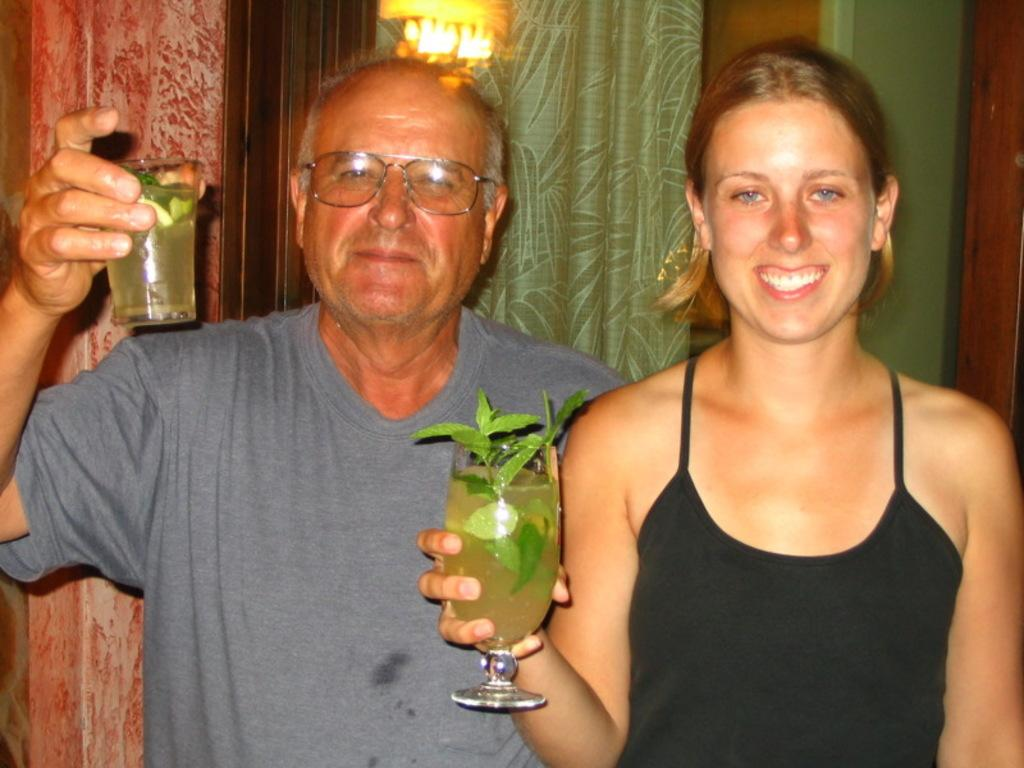How many people are present in the image? There are two people in the image, a man and a woman. What are the man and woman doing in the image? Both the man and woman are standing and holding beverage glasses in their hands. What can be seen in the background of the image? There is a door and curtains in the background of the image. What type of bait is the man using to catch fish in the image? There is no fishing or bait present in the image; it features a man and a woman holding beverage glasses. What is the woman's voice like in the image? There is no indication of the woman's voice in the image, as it is a still photograph. 